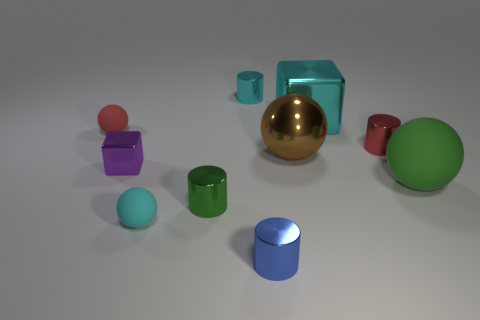Is the number of small gray shiny spheres less than the number of tiny red cylinders?
Your answer should be compact. Yes. What number of metal objects are the same shape as the green rubber object?
Your answer should be very brief. 1. What color is the other matte thing that is the same size as the cyan rubber thing?
Keep it short and to the point. Red. Is the number of small cyan rubber objects that are to the right of the tiny green thing the same as the number of small green metal things that are behind the red matte sphere?
Ensure brevity in your answer.  Yes. Is there a cyan metal cylinder of the same size as the red ball?
Keep it short and to the point. Yes. What size is the blue cylinder?
Offer a terse response. Small. Are there the same number of green cylinders that are in front of the blue metallic object and large blue matte balls?
Ensure brevity in your answer.  Yes. How many other objects are there of the same color as the large metallic block?
Give a very brief answer. 2. There is a cylinder that is both in front of the small red cylinder and behind the tiny cyan sphere; what color is it?
Ensure brevity in your answer.  Green. What is the size of the cyan metallic object in front of the cyan shiny object to the left of the metallic cube behind the purple thing?
Your answer should be compact. Large. 